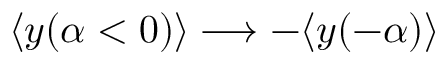<formula> <loc_0><loc_0><loc_500><loc_500>\langle y ( \alpha < 0 ) \rangle \longrightarrow - \langle y ( - \alpha ) \rangle</formula> 